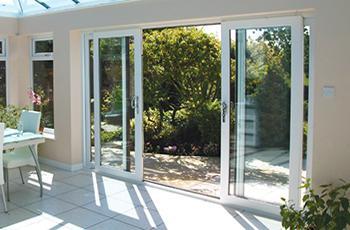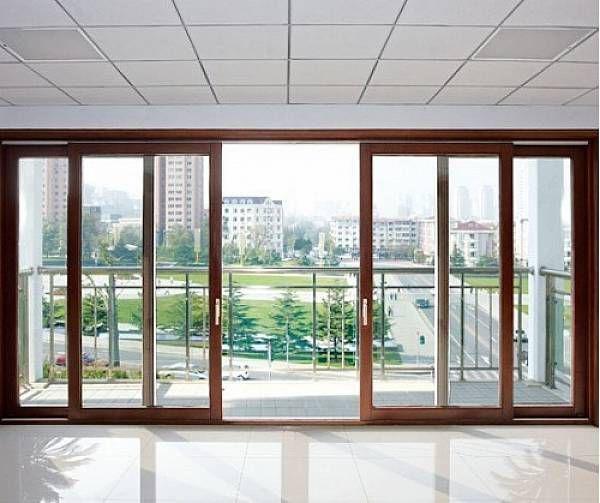The first image is the image on the left, the second image is the image on the right. Examine the images to the left and right. Is the description "In at least one image there are four closed tinted windows with white trim." accurate? Answer yes or no. No. 